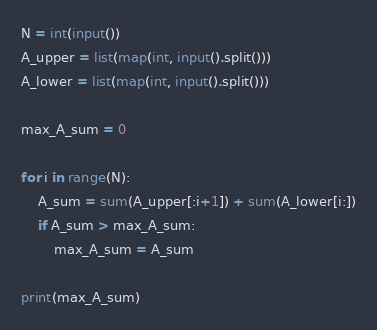<code> <loc_0><loc_0><loc_500><loc_500><_Python_>N = int(input())
A_upper = list(map(int, input().split()))
A_lower = list(map(int, input().split()))

max_A_sum = 0

for i in range(N):
    A_sum = sum(A_upper[:i+1]) + sum(A_lower[i:])
    if A_sum > max_A_sum:
        max_A_sum = A_sum

print(max_A_sum)

</code> 